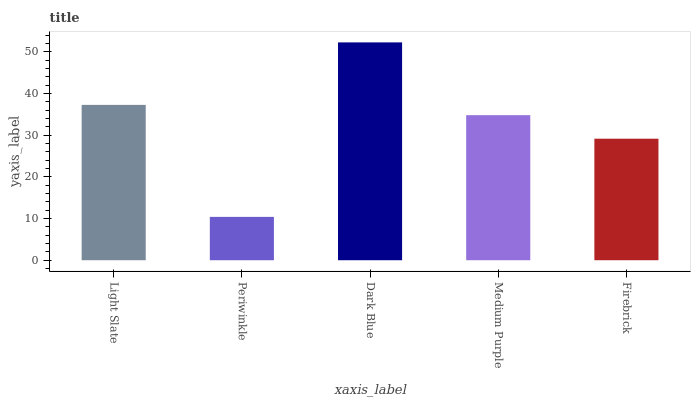Is Periwinkle the minimum?
Answer yes or no. Yes. Is Dark Blue the maximum?
Answer yes or no. Yes. Is Dark Blue the minimum?
Answer yes or no. No. Is Periwinkle the maximum?
Answer yes or no. No. Is Dark Blue greater than Periwinkle?
Answer yes or no. Yes. Is Periwinkle less than Dark Blue?
Answer yes or no. Yes. Is Periwinkle greater than Dark Blue?
Answer yes or no. No. Is Dark Blue less than Periwinkle?
Answer yes or no. No. Is Medium Purple the high median?
Answer yes or no. Yes. Is Medium Purple the low median?
Answer yes or no. Yes. Is Light Slate the high median?
Answer yes or no. No. Is Periwinkle the low median?
Answer yes or no. No. 